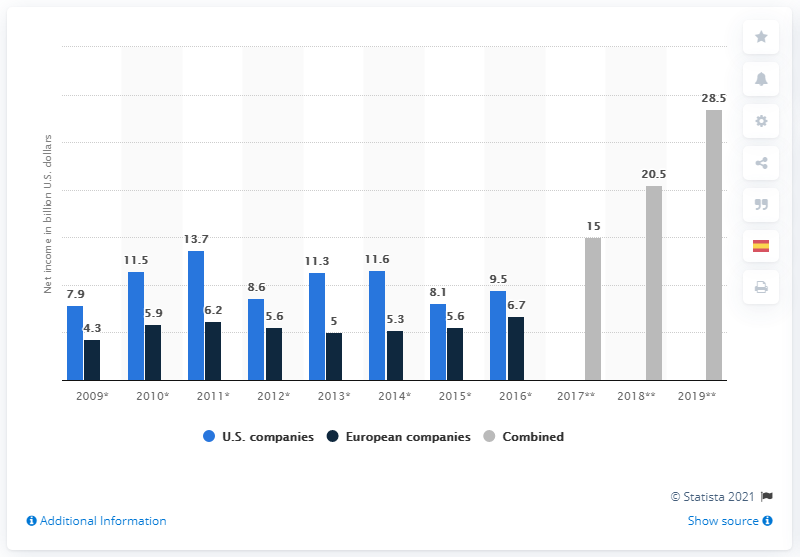What was the combined net income of US and European companies in 2017? The combined net income for US and European companies in 2017 was quite substantial. According to the chart, US companies had a net income of around $15 billion and European companies had about $6.7 billion, resulting in a total of approximately $21.7 billion. In which year did US companies show the highest net income according to the graph? Based on the graph, US companies displayed the highest net income in 2019, with a remarkable figure of roughly $28.5 billion. 